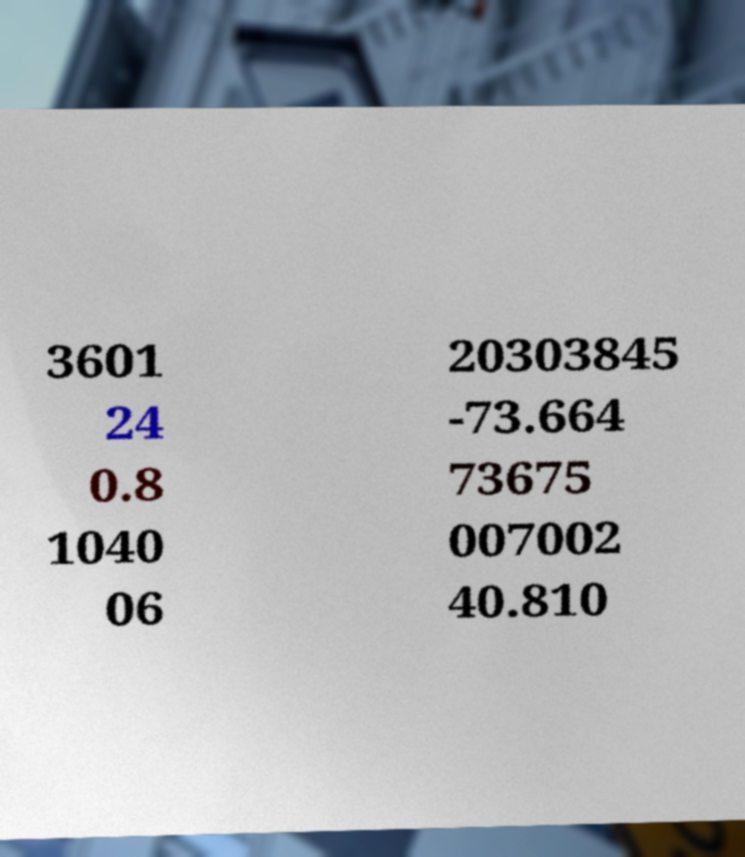For documentation purposes, I need the text within this image transcribed. Could you provide that? 3601 24 0.8 1040 06 20303845 -73.664 73675 007002 40.810 